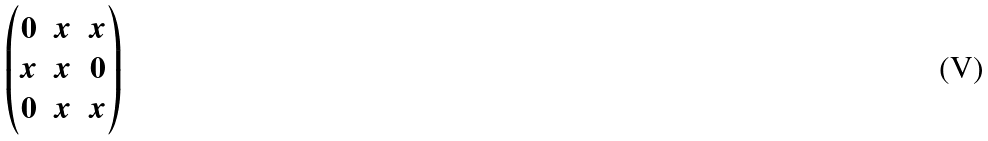Convert formula to latex. <formula><loc_0><loc_0><loc_500><loc_500>\begin{pmatrix} 0 & x & x \\ x & x & 0 \\ 0 & x & x \\ \end{pmatrix}</formula> 